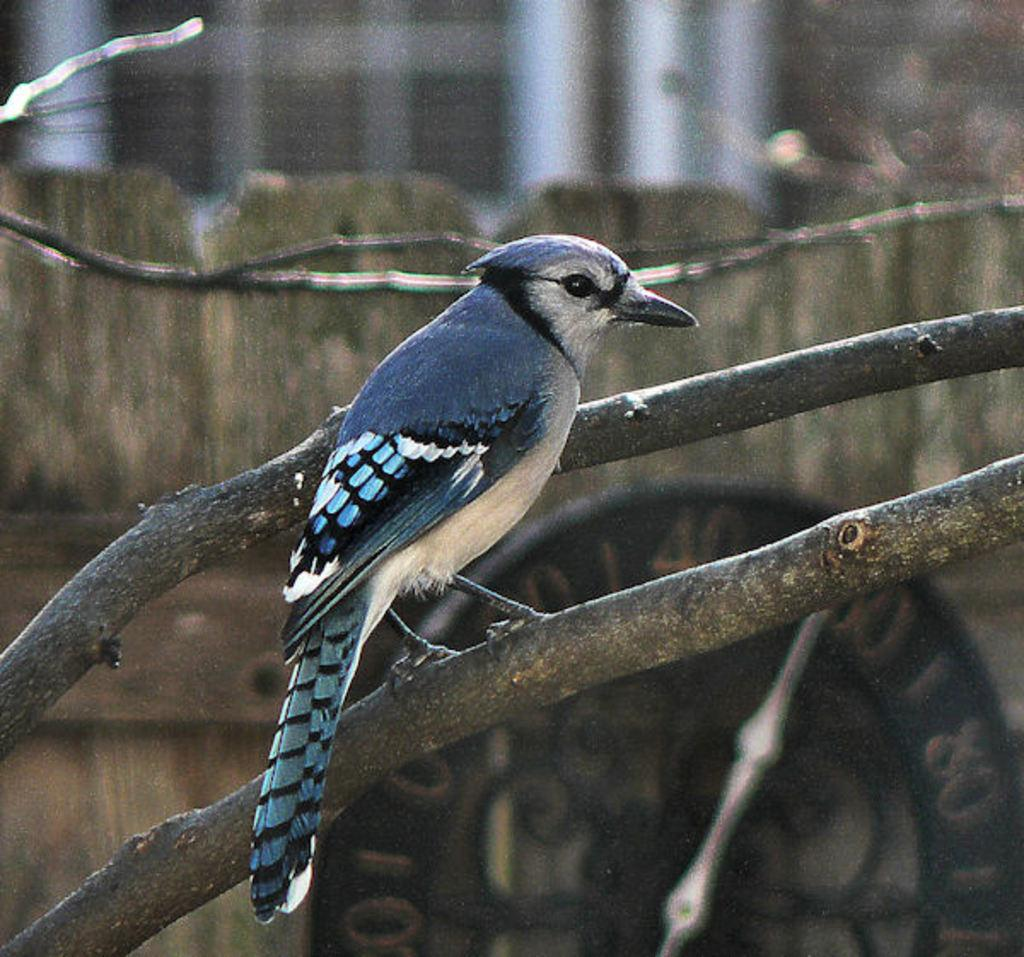What type of natural elements are visible in the image? The image contains branches of a tree. What animal can be seen in the image? There is a bird in the center of the image. What man-made object is present in the image? A clock is present at the bottom of the image. Can you describe the background of the image? The background of the image is blurred. What type of horn can be heard in the image? There is no horn present in the image, and therefore no sound can be heard. 